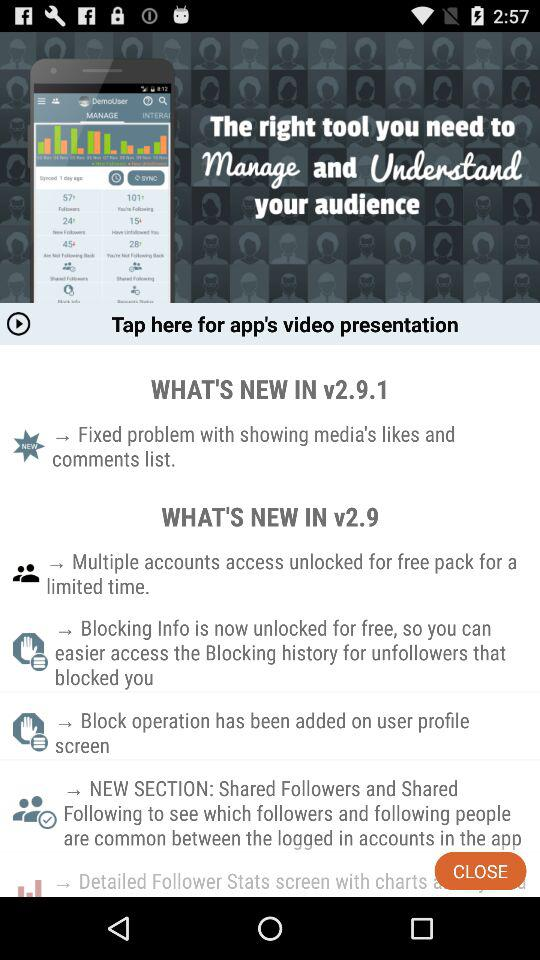In which version was access to multiple accounts unlocked for the free pack for a limited time? Access to multiple accounts for the free pack for a limited time was unlocked in v2.9. 